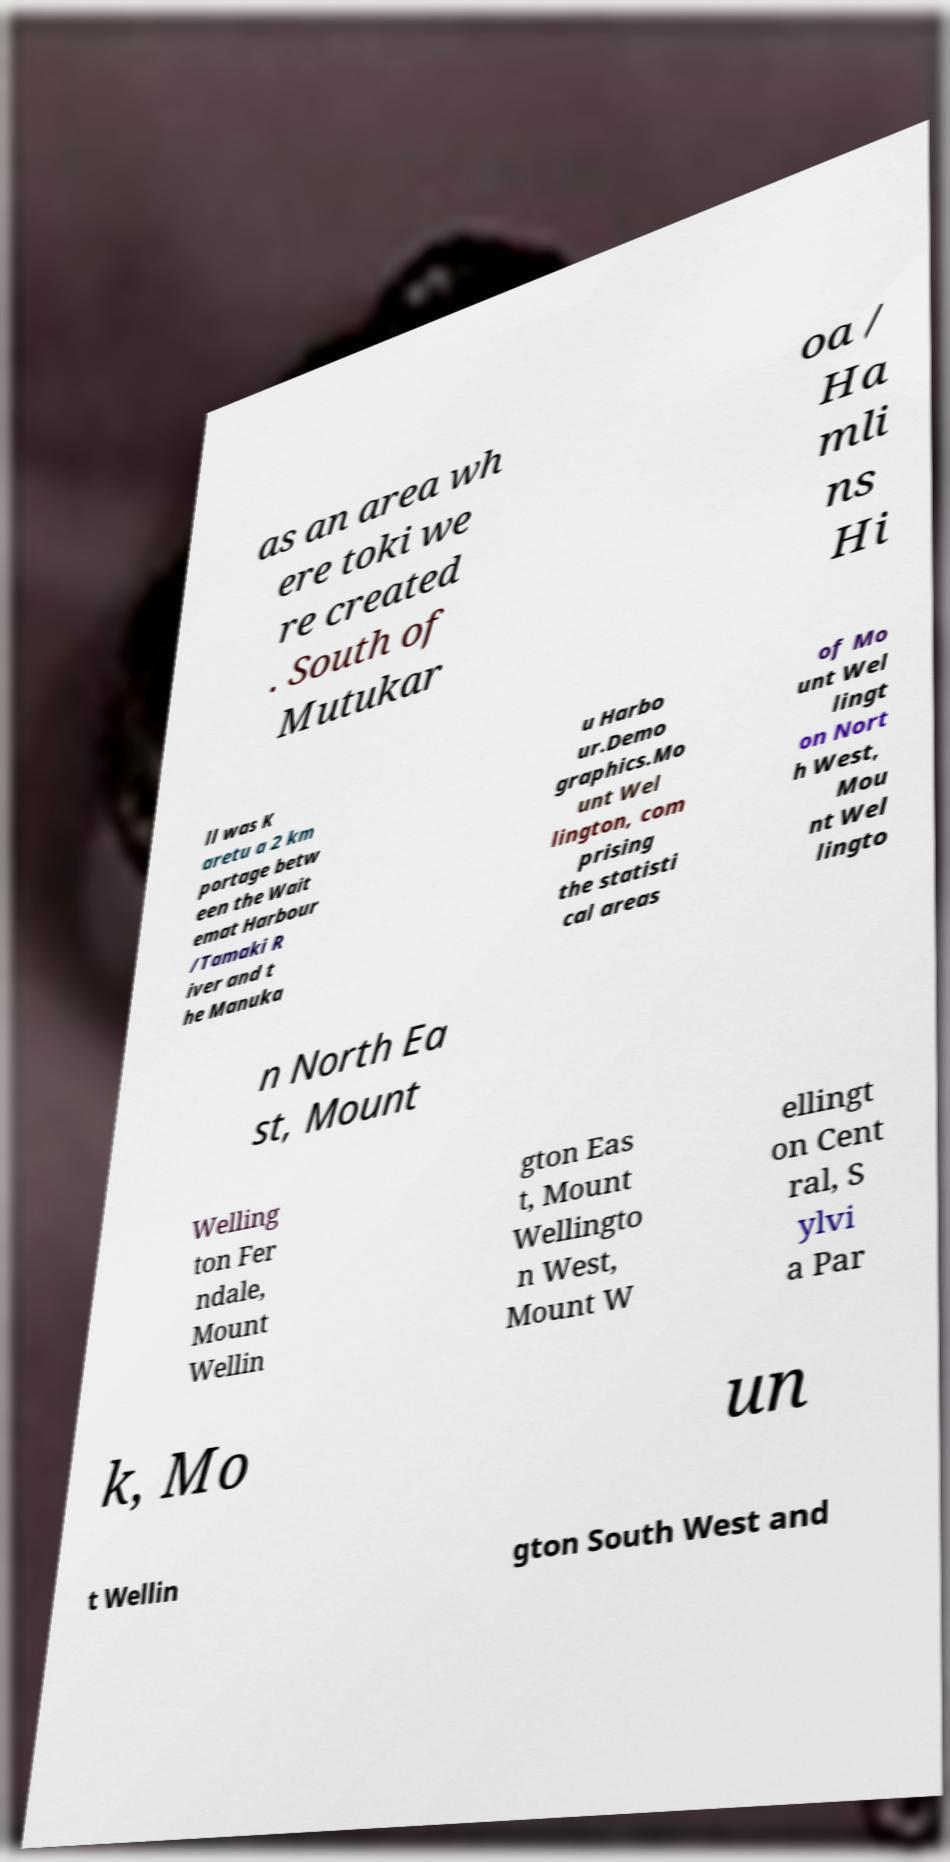I need the written content from this picture converted into text. Can you do that? as an area wh ere toki we re created . South of Mutukar oa / Ha mli ns Hi ll was K aretu a 2 km portage betw een the Wait emat Harbour /Tamaki R iver and t he Manuka u Harbo ur.Demo graphics.Mo unt Wel lington, com prising the statisti cal areas of Mo unt Wel lingt on Nort h West, Mou nt Wel lingto n North Ea st, Mount Welling ton Fer ndale, Mount Wellin gton Eas t, Mount Wellingto n West, Mount W ellingt on Cent ral, S ylvi a Par k, Mo un t Wellin gton South West and 